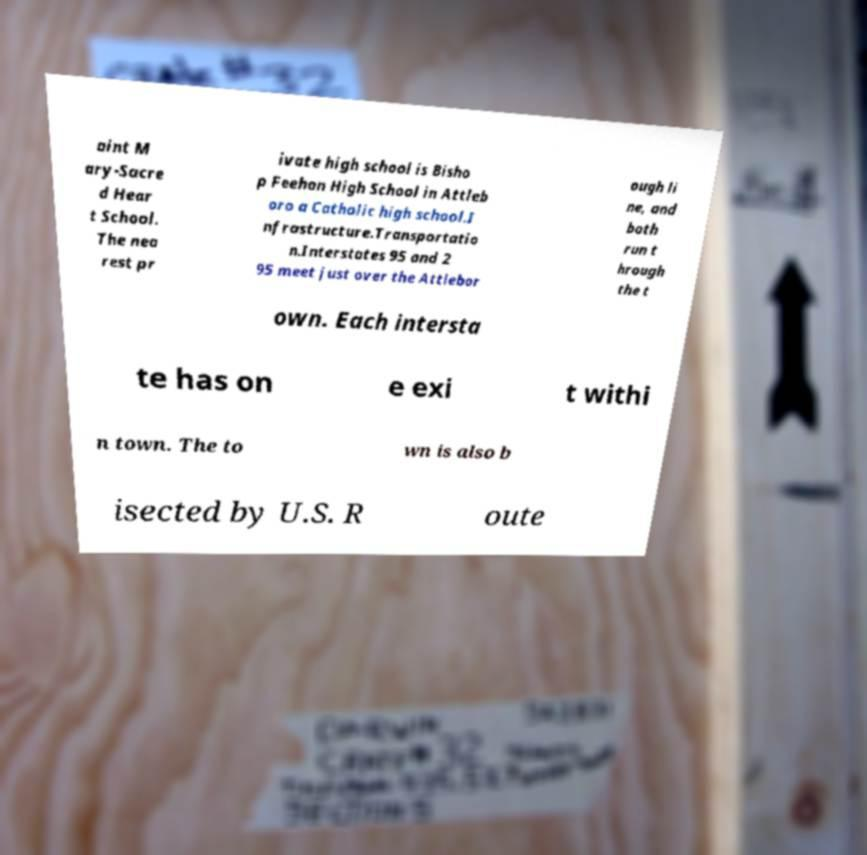Please identify and transcribe the text found in this image. aint M ary-Sacre d Hear t School. The nea rest pr ivate high school is Bisho p Feehan High School in Attleb oro a Catholic high school.I nfrastructure.Transportatio n.Interstates 95 and 2 95 meet just over the Attlebor ough li ne, and both run t hrough the t own. Each intersta te has on e exi t withi n town. The to wn is also b isected by U.S. R oute 